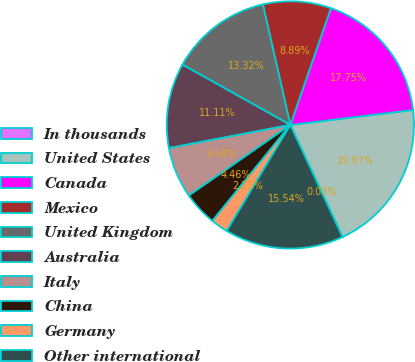Convert chart to OTSL. <chart><loc_0><loc_0><loc_500><loc_500><pie_chart><fcel>In thousands<fcel>United States<fcel>Canada<fcel>Mexico<fcel>United Kingdom<fcel>Australia<fcel>Italy<fcel>China<fcel>Germany<fcel>Other international<nl><fcel>0.03%<fcel>19.97%<fcel>17.75%<fcel>8.89%<fcel>13.32%<fcel>11.11%<fcel>6.68%<fcel>4.46%<fcel>2.25%<fcel>15.54%<nl></chart> 